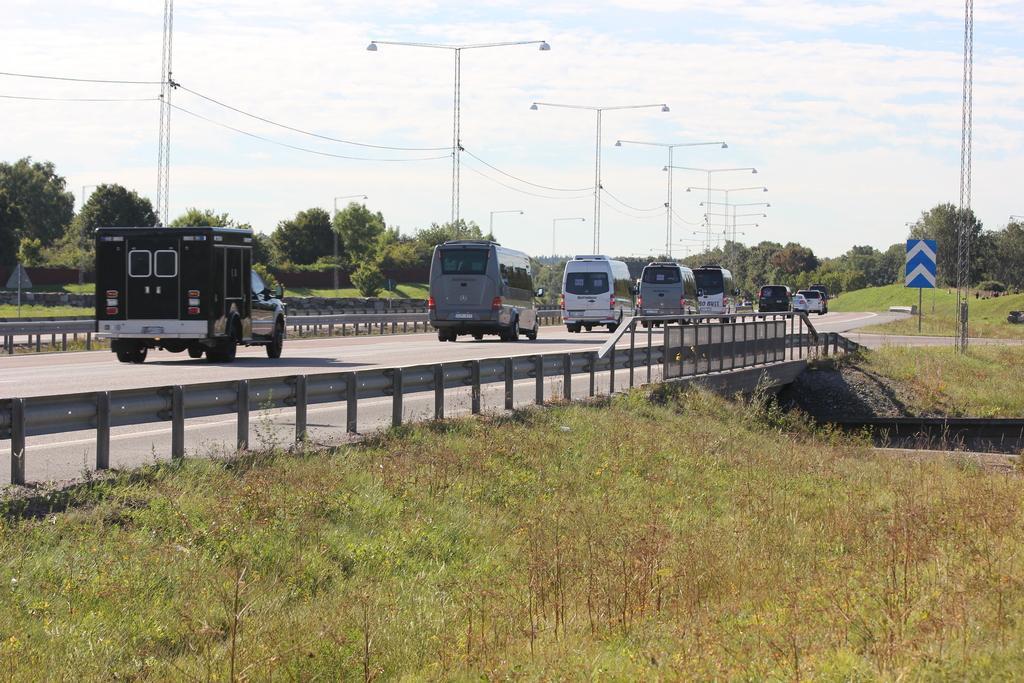Can you describe this image briefly? In this image I can see few vehicles on the road. In the background I can see few plants and trees in green color, few light poles and the sky is in blue and white color. 